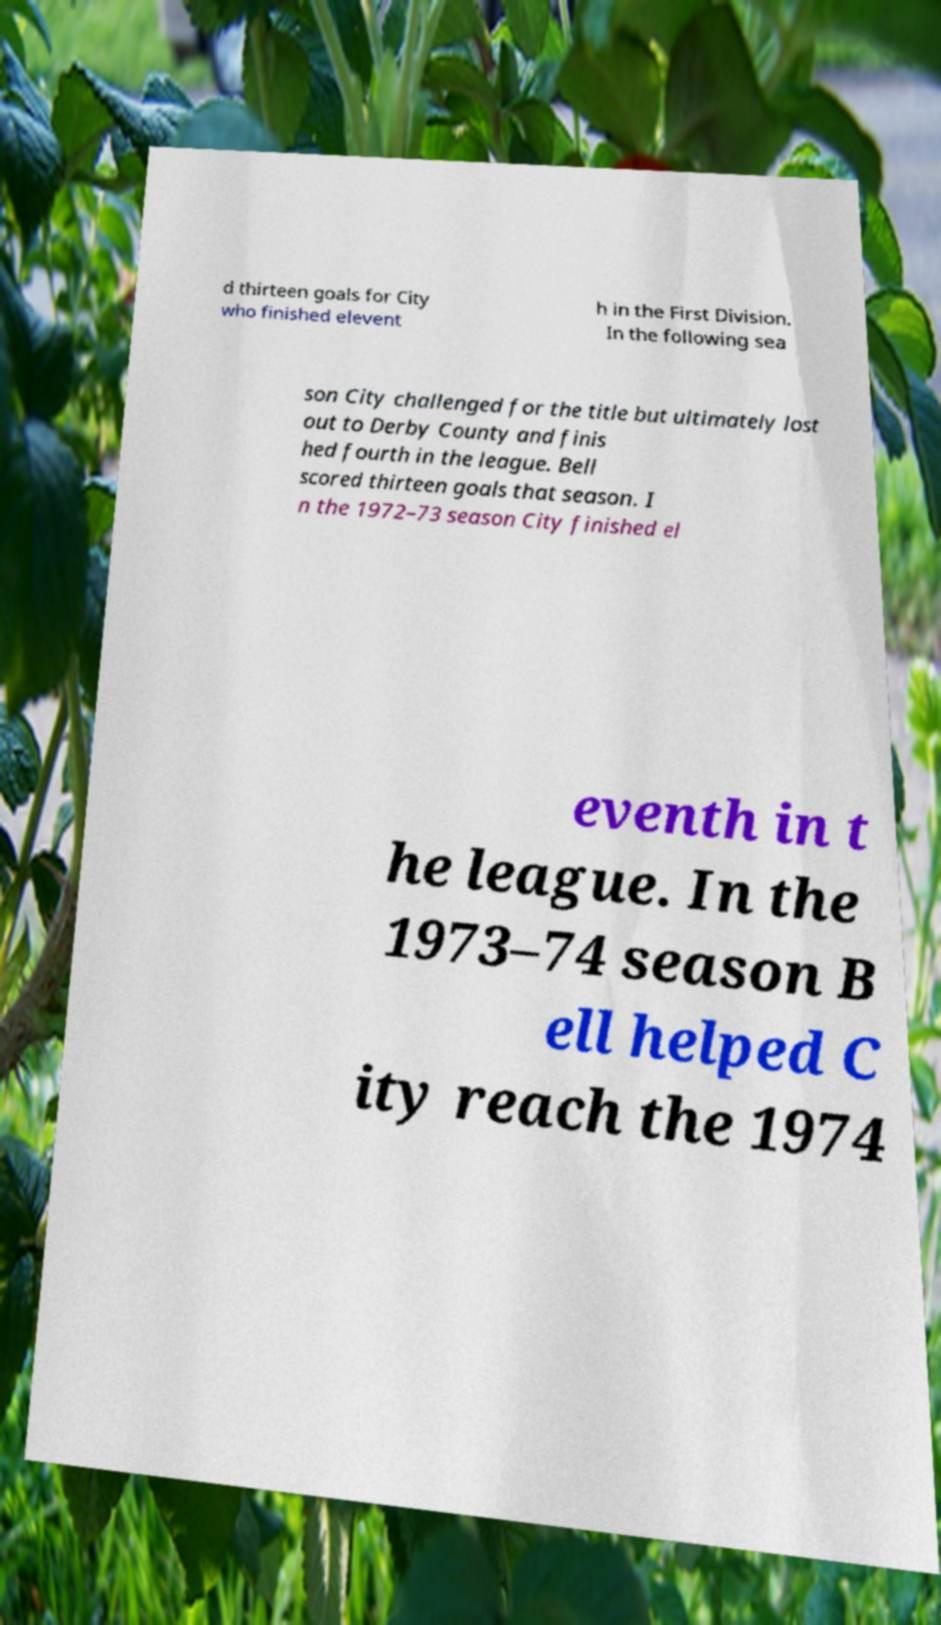There's text embedded in this image that I need extracted. Can you transcribe it verbatim? d thirteen goals for City who finished elevent h in the First Division. In the following sea son City challenged for the title but ultimately lost out to Derby County and finis hed fourth in the league. Bell scored thirteen goals that season. I n the 1972–73 season City finished el eventh in t he league. In the 1973–74 season B ell helped C ity reach the 1974 